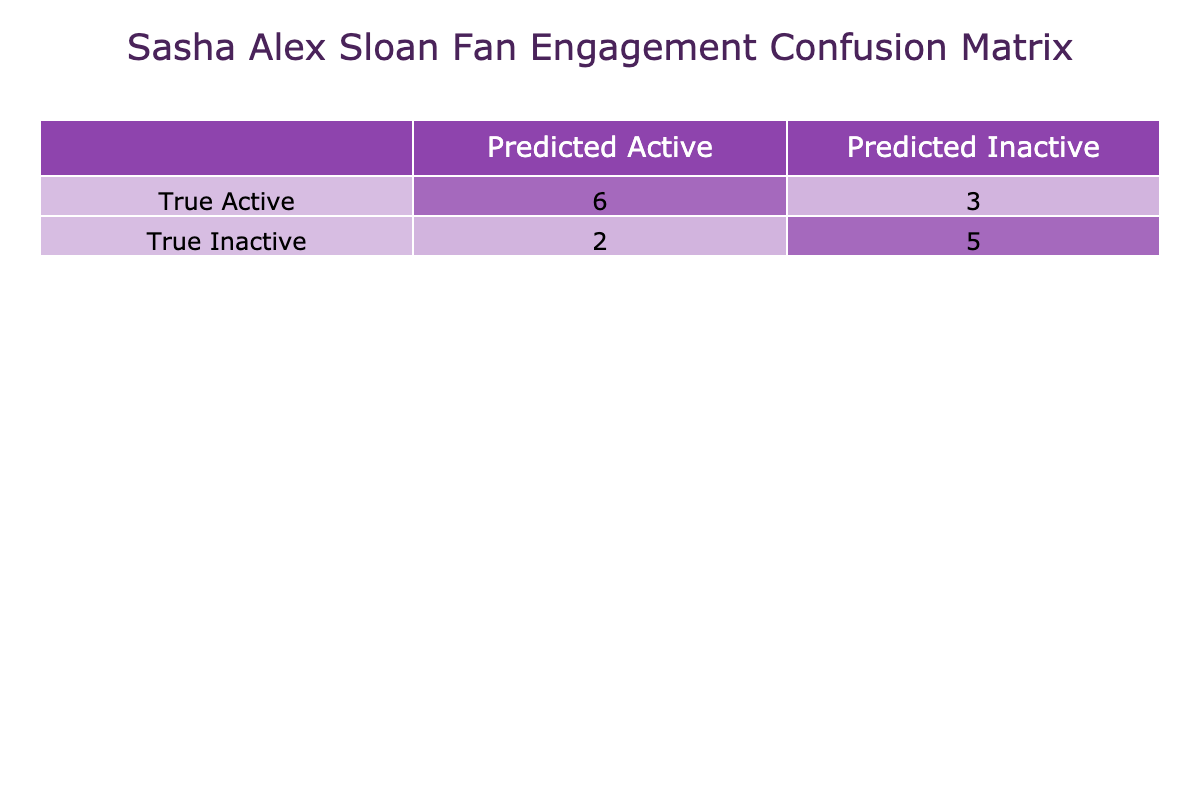What is the number of true positives (TP)? True positives are those instances where the true label is "Active" and the predicted label is also "Active." From the table, there are 7 instances where both labels are "Active."
Answer: 7 What is the number of false negatives (FN)? False negatives are instances where the true label is "Active," but the predicted label is "Inactive." By checking the table, there are 3 instances meeting this criterion.
Answer: 3 What is the number of true negatives (TN)? True negatives refer to instances where the true label is "Inactive," and the predicted label is also "Inactive." The table lists 4 such instances, thus the answer is 4.
Answer: 4 What is the number of false positives (FP)? False positives occur when the true label is "Inactive," but the predicted label is "Active." The table reveals 2 cases where this happens, leading to the conclusion of 2.
Answer: 2 What is the accuracy of the model? Accuracy is calculated as (TP + TN) / Total Instances. Here, TP = 7, TN = 4, and Total Instances = 15. So, the accuracy is (7 + 4) / 15 = 11 / 15 ≈ 0.733 or approximately 73.3%.
Answer: 73.3% Are there more true positives than true negatives? To determine this, we compare the values: true positives (7) and true negatives (4). Since 7 is greater than 4, the answer is yes.
Answer: Yes Did the model predict any inactive fans as active fans? This question looks for instances where the true label was "Inactive," but the prediction was "Active," which are known as false positives. Checking the table reveals there were 2 such cases, confirming that the answer is yes.
Answer: Yes What is the combined total of false positives and false negatives? To find this total, we add false positives (2) and false negatives (3). Thus, the total is 2 + 3 = 5, leading us to conclude that the answer is 5.
Answer: 5 What is the total number of instances classified as 'Active'? We need to sum the numbers of true positives (7) and false positives (2) to find the total instances classified as "Active." Therefore, 7 + 2 = 9 indicates that the answer is 9.
Answer: 9 What is the ratio of true positives to false negatives? To find the ratio, we take the number of true positives (7) and divide it by the number of false negatives (3). This ratio is 7:3 or simplified as 7/3. Thus the answer can be expressed as 7:3.
Answer: 7:3 